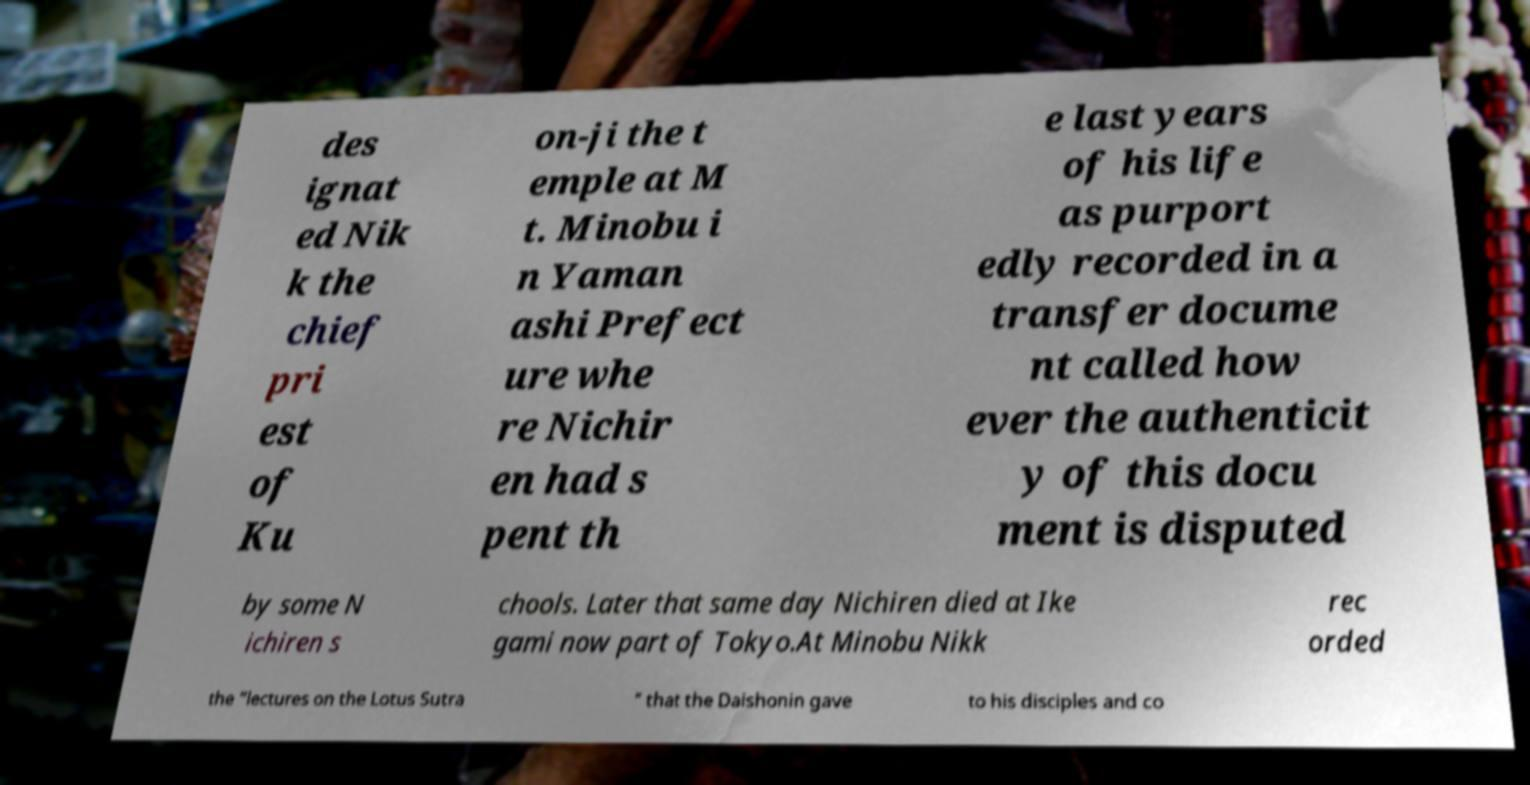For documentation purposes, I need the text within this image transcribed. Could you provide that? des ignat ed Nik k the chief pri est of Ku on-ji the t emple at M t. Minobu i n Yaman ashi Prefect ure whe re Nichir en had s pent th e last years of his life as purport edly recorded in a transfer docume nt called how ever the authenticit y of this docu ment is disputed by some N ichiren s chools. Later that same day Nichiren died at Ike gami now part of Tokyo.At Minobu Nikk rec orded the “lectures on the Lotus Sutra ” that the Daishonin gave to his disciples and co 